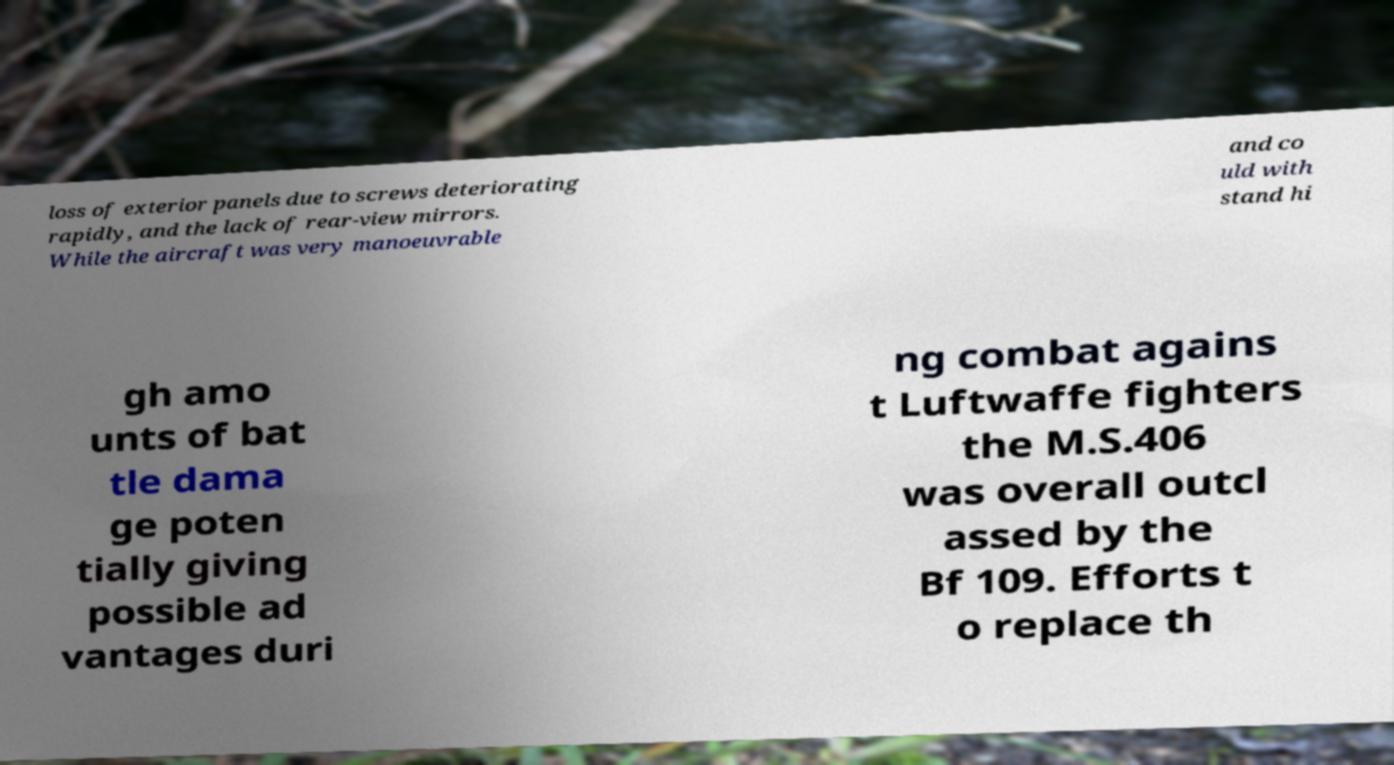I need the written content from this picture converted into text. Can you do that? loss of exterior panels due to screws deteriorating rapidly, and the lack of rear-view mirrors. While the aircraft was very manoeuvrable and co uld with stand hi gh amo unts of bat tle dama ge poten tially giving possible ad vantages duri ng combat agains t Luftwaffe fighters the M.S.406 was overall outcl assed by the Bf 109. Efforts t o replace th 